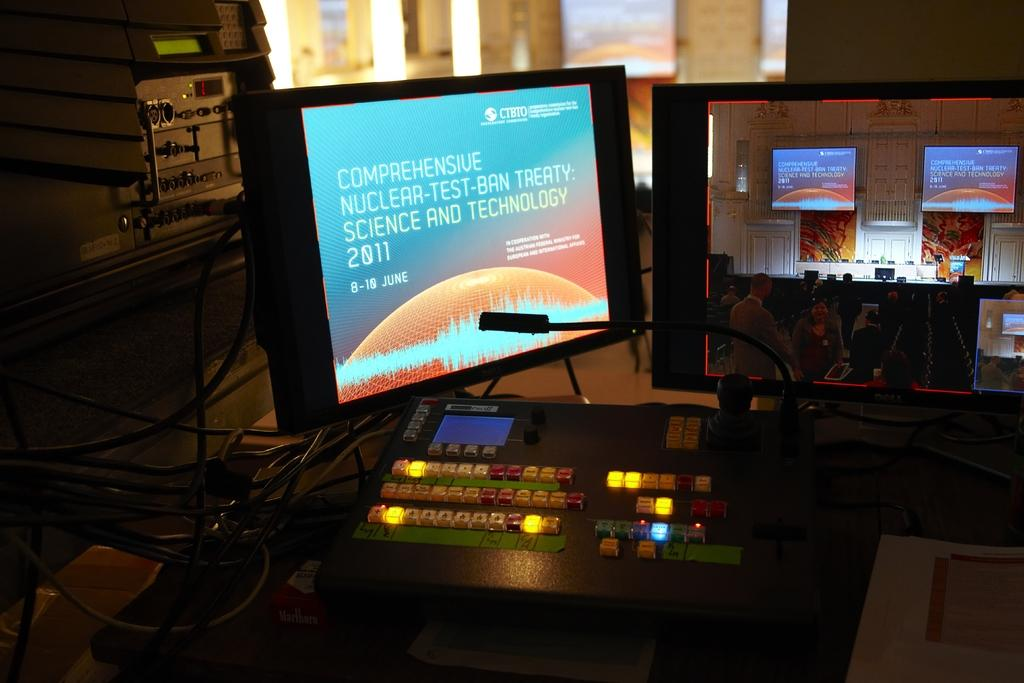<image>
Provide a brief description of the given image. A computer screen is open to a slideshow about "Comprehensive Nuclear-Test-Ban-Treaty" 